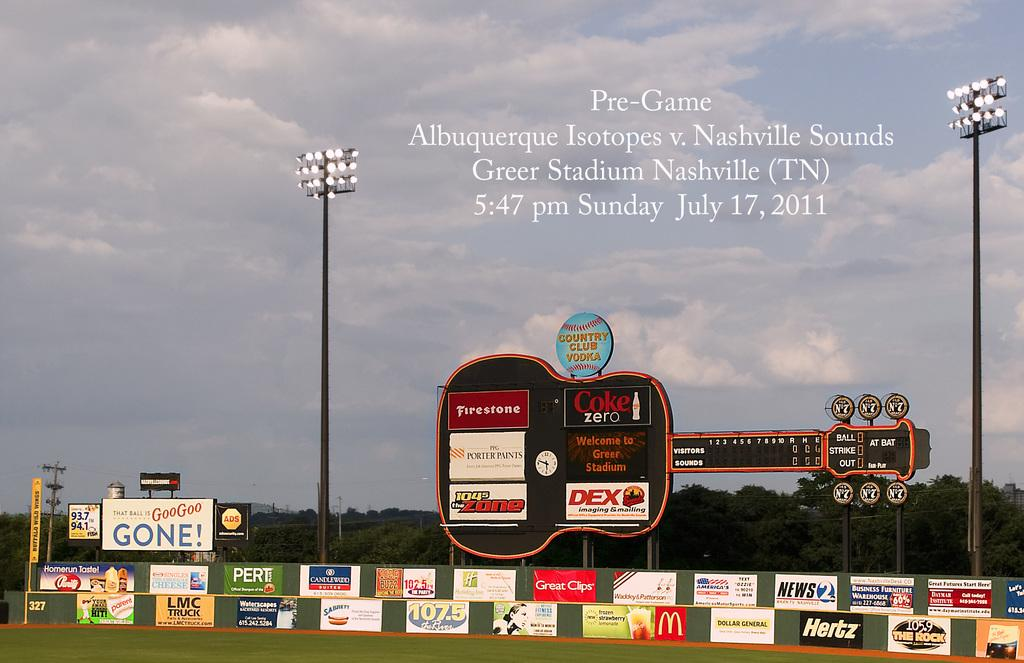<image>
Give a short and clear explanation of the subsequent image. Albuquerque Isotopes are playing the Nashville Sounds on Sunday, July 17th at Greer Stadium. 